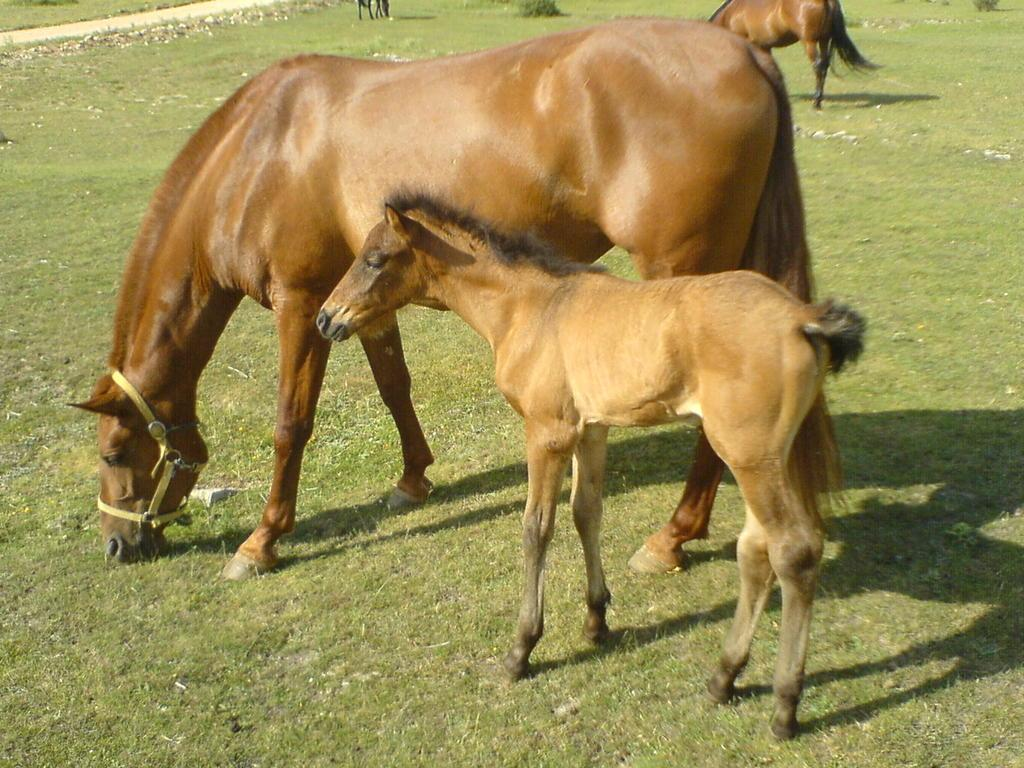What animals can be seen in the image? There is a horse and a pony in the image. Where are the horse and pony located? Both the horse and pony are on a grassland. Are there any other horses in the image? Yes, there is another horse at the top side of the image. What type of furniture can be seen in the image? There is no furniture present in the image; it features a horse, a pony, and another horse on a grassland. Are there any balloons in the image? There are no balloons present in the image. 